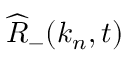Convert formula to latex. <formula><loc_0><loc_0><loc_500><loc_500>\widehat { R } _ { - } ( k _ { n } , t )</formula> 